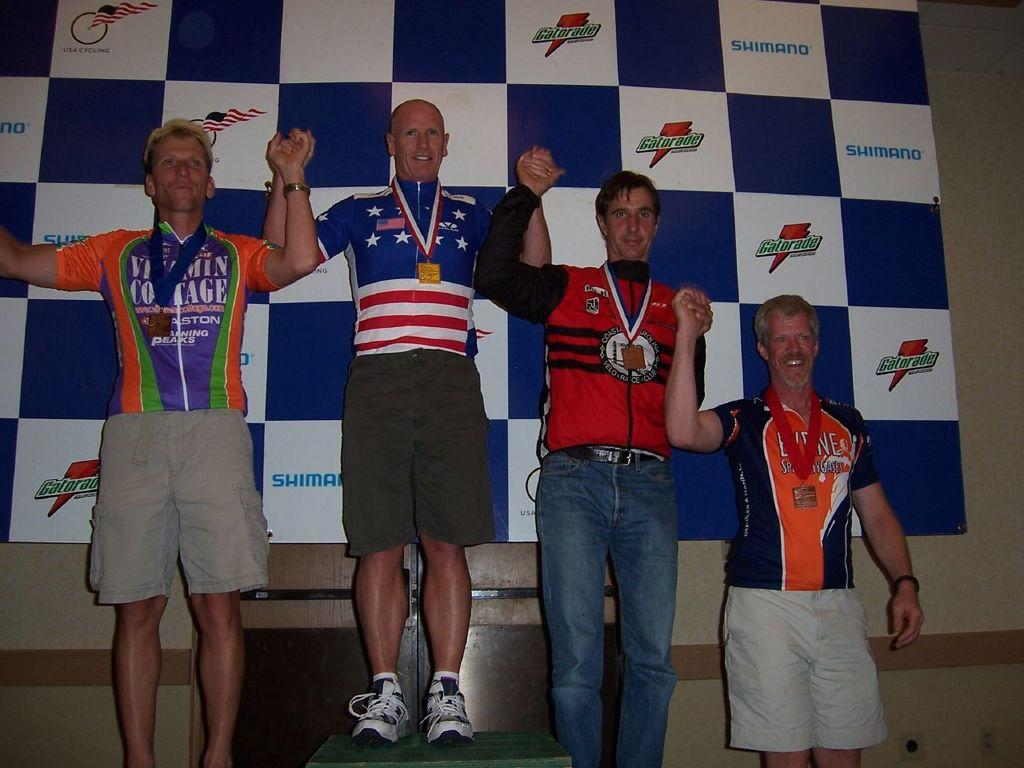Provide a one-sentence caption for the provided image. some Olympic winners sponsored by Gatorade in the back of them. 